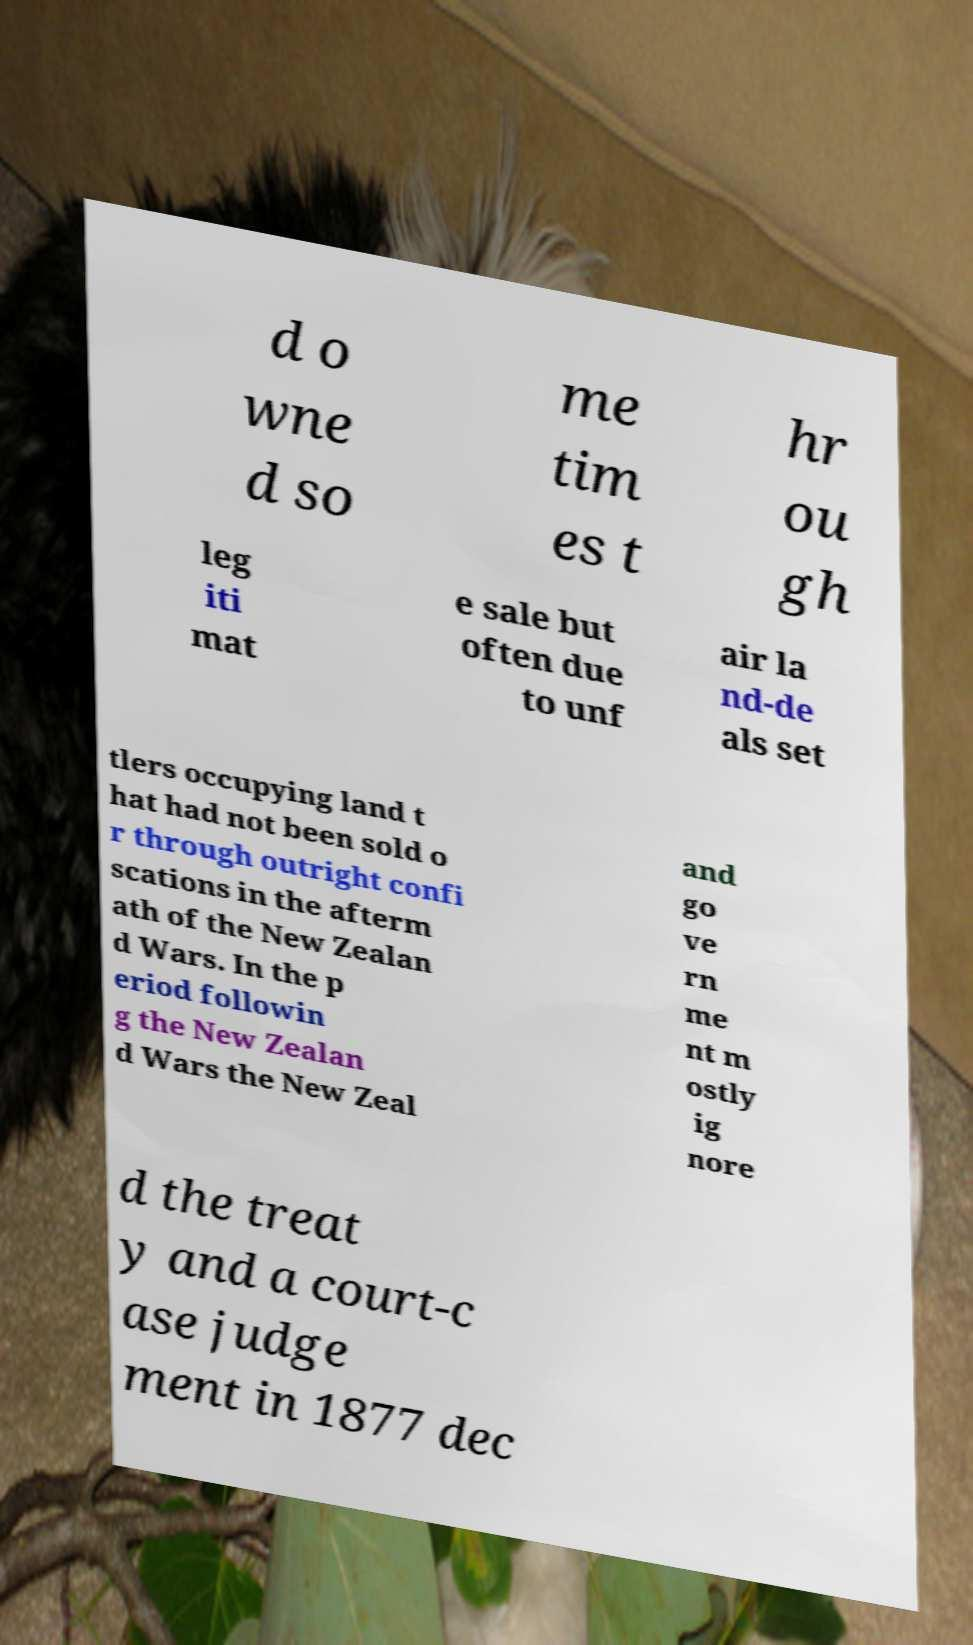There's text embedded in this image that I need extracted. Can you transcribe it verbatim? d o wne d so me tim es t hr ou gh leg iti mat e sale but often due to unf air la nd-de als set tlers occupying land t hat had not been sold o r through outright confi scations in the afterm ath of the New Zealan d Wars. In the p eriod followin g the New Zealan d Wars the New Zeal and go ve rn me nt m ostly ig nore d the treat y and a court-c ase judge ment in 1877 dec 